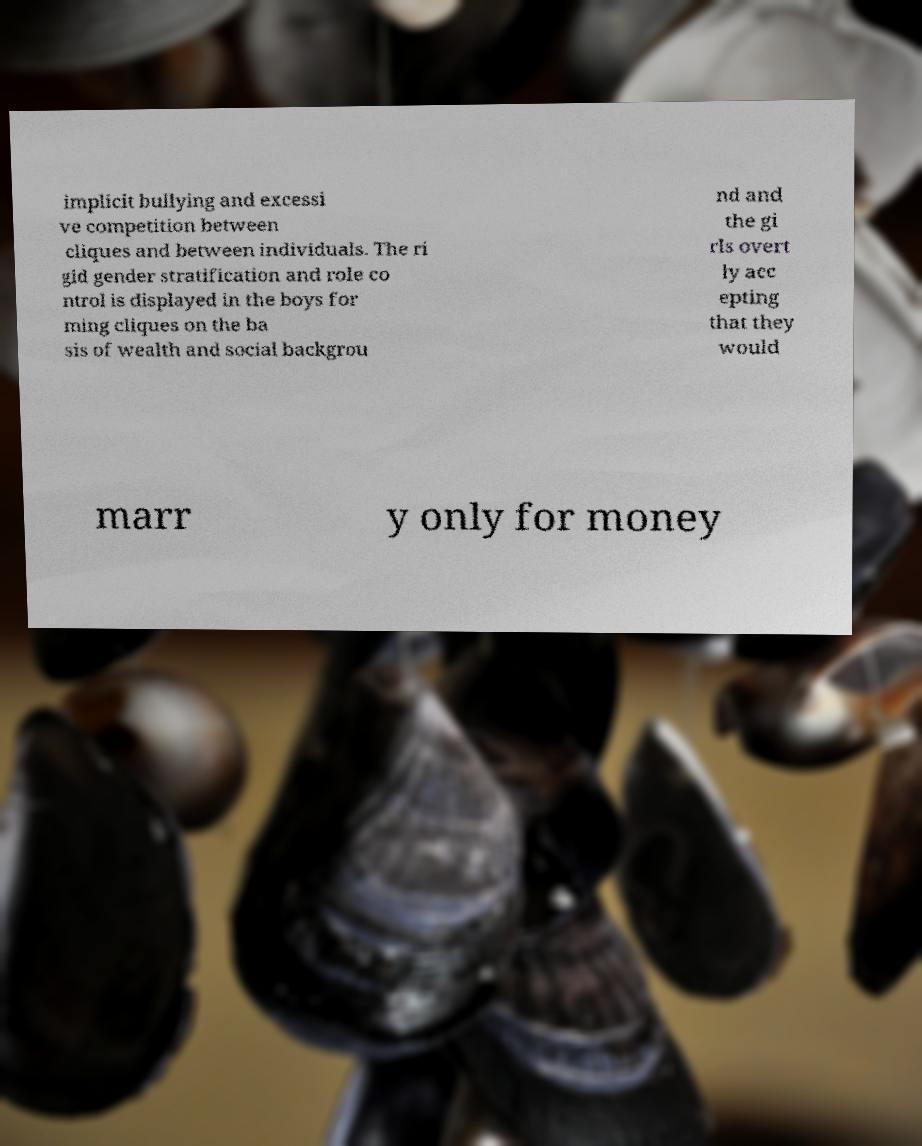There's text embedded in this image that I need extracted. Can you transcribe it verbatim? implicit bullying and excessi ve competition between cliques and between individuals. The ri gid gender stratification and role co ntrol is displayed in the boys for ming cliques on the ba sis of wealth and social backgrou nd and the gi rls overt ly acc epting that they would marr y only for money 